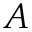<formula> <loc_0><loc_0><loc_500><loc_500>A</formula> 